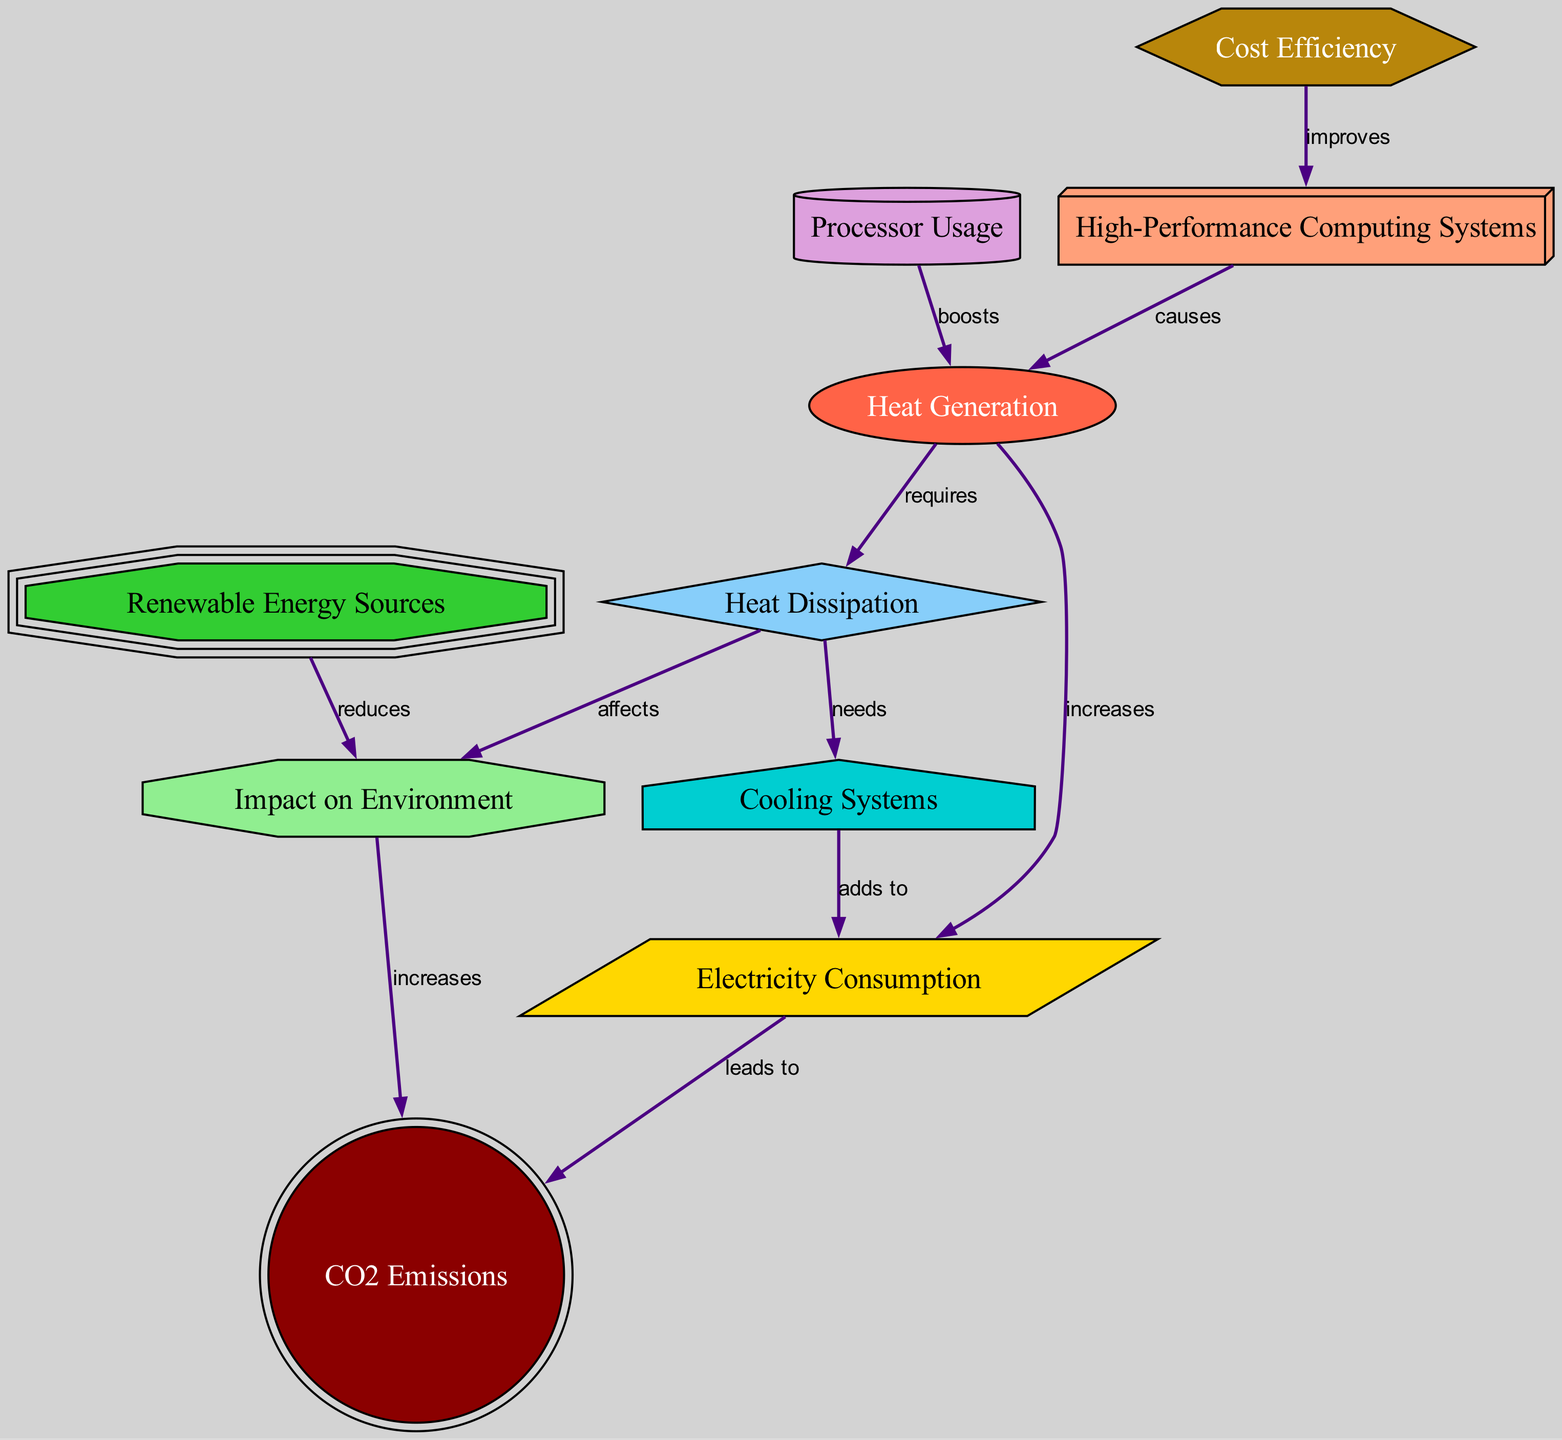What is the total number of nodes in the diagram? There are ten nodes represented in the diagram, each corresponding to a specific concept related to heat generation and dissipation.
Answer: 10 What does "Processor Usage" do to "Heat Generation"? The diagram indicates that "Processor Usage" boosts "Heat Generation." This means that as processor usage increases, the heat generated by high-performance computing systems also increases.
Answer: boosts What is the relationship between "Electricity Consumption" and "CO2 Emissions"? The diagram specifies that "Electricity Consumption" leads to "CO2 Emissions," indicating that increased electricity usage contributes to higher carbon dioxide emissions from energy generation.
Answer: leads to Which node reduces the "Impact on Environment"? According to the diagram, "Renewable Energy Sources" are indicated to reduce the "Impact on Environment," suggesting that using renewable energy can lessen the environmental effects associated with computing systems.
Answer: reduces How many edges are there connecting nodes in the diagram? By counting the relationships shown between the nodes (edges), we find that there are 10 edges in total, indicating how the different factors interact with each other.
Answer: 10 What does "Cooling Systems" need to operate effectively? The diagram shows that "Cooling Systems" need "Heat Dissipation" to function properly, signifying that effective cooling is dependent on managing the heat generated by computing processes.
Answer: needs What is the effect of "Heat Dissipation" on "Environment Impact"? The diagram states that "Heat Dissipation" affects "Environment Impact," meaning that the way heat is managed can have direct consequences for the environment.
Answer: affects How does "Cost Efficiency" relate to "High-Performance Computing Systems"? The diagram indicates that "Cost Efficiency" improves "High-Performance Computing Systems," pointing out that optimizing costs can enhance the overall performance of these systems.
Answer: improves What does increased "Electricity Consumption" lead to at the environment level? The diagram clearly shows that increased "Electricity Consumption" leads to "CO2 Emissions," indicating an adverse environmental impact associated with higher electricity use.
Answer: leads to 